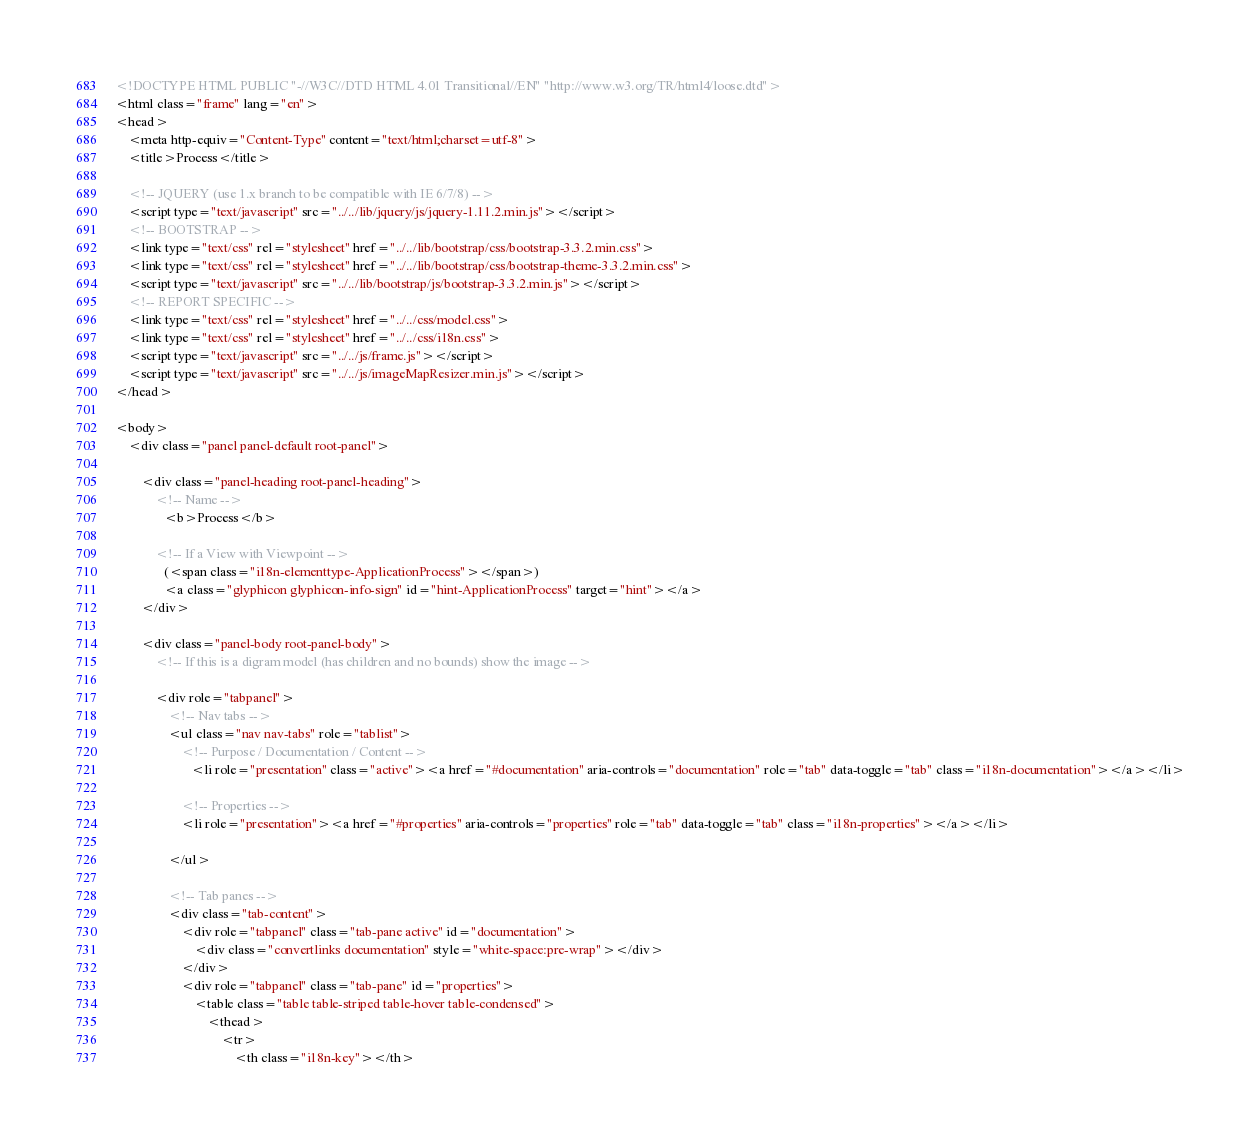<code> <loc_0><loc_0><loc_500><loc_500><_HTML_><!DOCTYPE HTML PUBLIC "-//W3C//DTD HTML 4.01 Transitional//EN" "http://www.w3.org/TR/html4/loose.dtd">
<html class="frame" lang="en">
<head>
	<meta http-equiv="Content-Type" content="text/html;charset=utf-8">
	<title>Process</title>

	<!-- JQUERY (use 1.x branch to be compatible with IE 6/7/8) -->
	<script type="text/javascript" src="../../lib/jquery/js/jquery-1.11.2.min.js"></script>
	<!-- BOOTSTRAP -->
	<link type="text/css" rel="stylesheet" href="../../lib/bootstrap/css/bootstrap-3.3.2.min.css">
	<link type="text/css" rel="stylesheet" href="../../lib/bootstrap/css/bootstrap-theme-3.3.2.min.css">
	<script type="text/javascript" src="../../lib/bootstrap/js/bootstrap-3.3.2.min.js"></script>
	<!-- REPORT SPECIFIC -->
	<link type="text/css" rel="stylesheet" href="../../css/model.css">
	<link type="text/css" rel="stylesheet" href="../../css/i18n.css">
	<script type="text/javascript" src="../../js/frame.js"></script>
	<script type="text/javascript" src="../../js/imageMapResizer.min.js"></script>
</head>

<body>
	<div class="panel panel-default root-panel">

		<div class="panel-heading root-panel-heading">
            <!-- Name -->
               <b>Process</b>

            <!-- If a View with Viewpoint -->
			   (<span class="i18n-elementtype-ApplicationProcess"></span>)
			   <a class="glyphicon glyphicon-info-sign" id="hint-ApplicationProcess" target="hint"></a>
		</div>

		<div class="panel-body root-panel-body">
		    <!-- If this is a digram model (has children and no bounds) show the image -->

			<div role="tabpanel">
				<!-- Nav tabs -->
				<ul class="nav nav-tabs" role="tablist">
                    <!-- Purpose / Documentation / Content -->
					   <li role="presentation" class="active"><a href="#documentation" aria-controls="documentation" role="tab" data-toggle="tab" class="i18n-documentation"></a></li>

                    <!-- Properties -->
                    <li role="presentation"><a href="#properties" aria-controls="properties" role="tab" data-toggle="tab" class="i18n-properties"></a></li>

				</ul>

				<!-- Tab panes -->
				<div class="tab-content">
					<div role="tabpanel" class="tab-pane active" id="documentation">
						<div class="convertlinks documentation" style="white-space:pre-wrap"></div>
					</div>
					<div role="tabpanel" class="tab-pane" id="properties">
						<table class="table table-striped table-hover table-condensed">
							<thead>
								<tr>
									<th class="i18n-key"></th></code> 